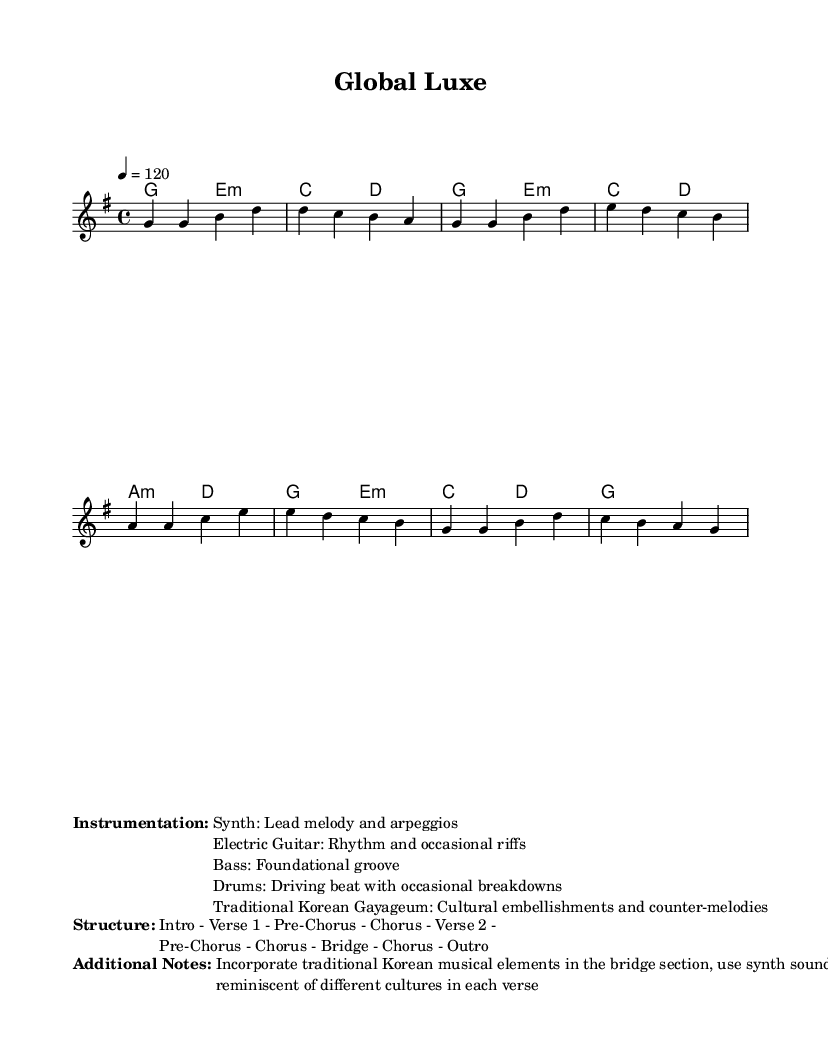What is the key signature of this music? The key signature indicates that the piece is in G major, which has one sharp (F#). You can find the key signature at the beginning of the staff.
Answer: G major What is the time signature of this music? The time signature is indicated in the sheet music and shows how many beats are in each measure. In this piece, it is 4/4, meaning there are four beats per measure.
Answer: 4/4 What is the tempo marking for this piece? The tempo marking is shown in the score; it indicates how fast the music should be played. Here, it is marked as "4 = 120," which means 120 beats per minute.
Answer: 120 How many measures are in the melody? By counting the individual phrases outlined in the melody section of the sheet music, we find that there are eight measures in total.
Answer: 8 What type of instrumentation is used for the lead melody? The lead melody uses a synthesizer, as specified in the instrumentation section that lists the synth as the lead instrument for melody and arpeggios.
Answer: Synth Which traditional instrument is incorporated into the music? The additional notes mention the use of the Gayageum, which is a traditional Korean instrument, indicating its cultural significance in the piece.
Answer: Gayageum How is the structure of the music organized? The structure indicates how the piece is organized, listing the order of sections from Intro to Outro. The sequence shows a repetition common in K-Pop, with verses, pre-choruses, and choruses clearly outlined.
Answer: Intro - Verse 1 - Pre-Chorus - Chorus - Verse 2 - Pre-Chorus - Chorus - Bridge - Chorus - Outro 